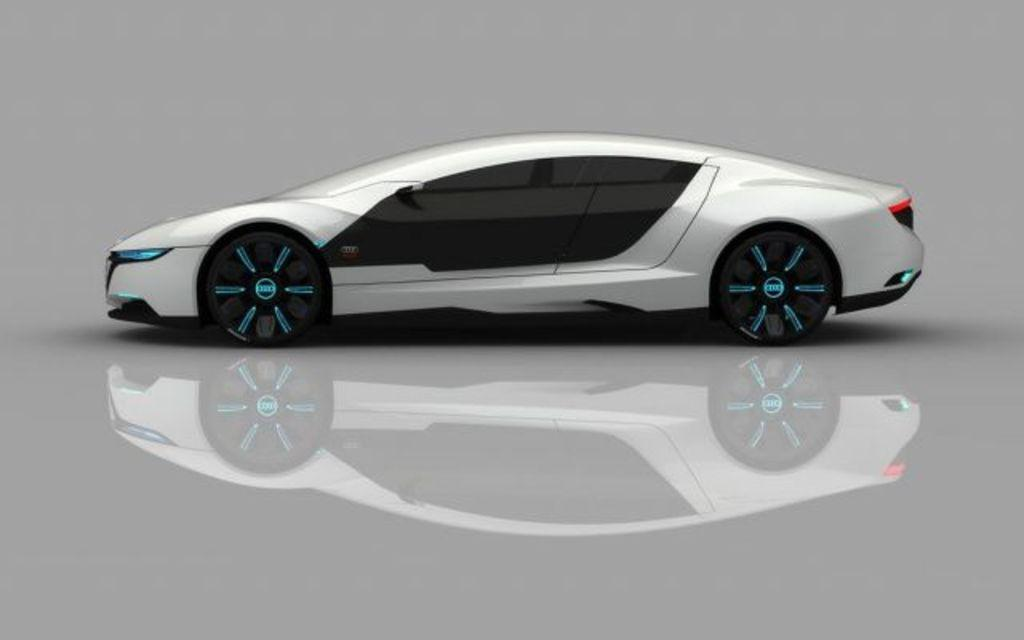What is the main subject in the center of the image? There is a car in the center of the image. What is the surface on which the car is situated? There is a floor visible at the bottom of the image. What type of berry is being used to cool down the car in the image? There is no berry present in the image, and the car is not being cooled down by any means. 